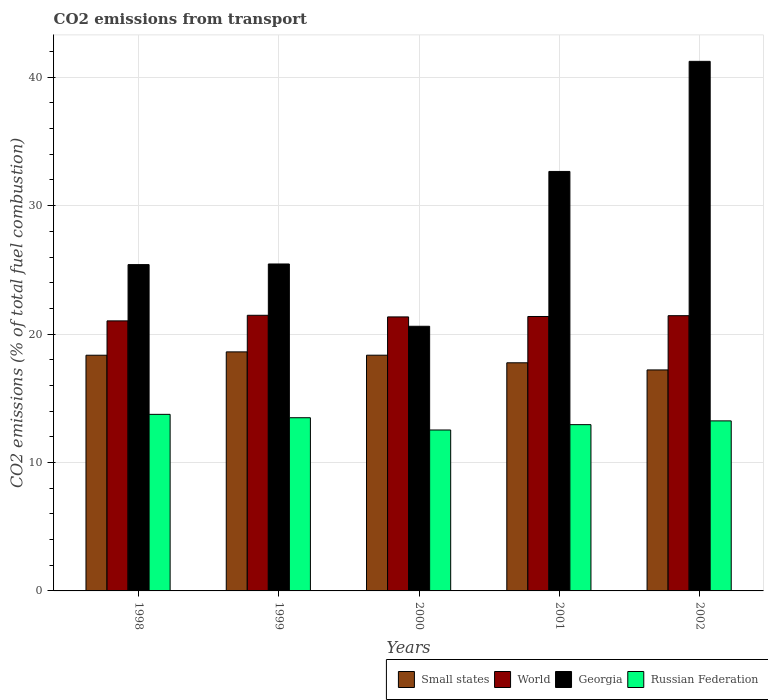How many groups of bars are there?
Ensure brevity in your answer.  5. Are the number of bars per tick equal to the number of legend labels?
Your response must be concise. Yes. Are the number of bars on each tick of the X-axis equal?
Make the answer very short. Yes. How many bars are there on the 2nd tick from the left?
Your answer should be very brief. 4. In how many cases, is the number of bars for a given year not equal to the number of legend labels?
Offer a very short reply. 0. What is the total CO2 emitted in Georgia in 1998?
Offer a very short reply. 25.41. Across all years, what is the maximum total CO2 emitted in Small states?
Ensure brevity in your answer.  18.61. Across all years, what is the minimum total CO2 emitted in Georgia?
Your response must be concise. 20.61. In which year was the total CO2 emitted in World maximum?
Provide a short and direct response. 1999. In which year was the total CO2 emitted in Russian Federation minimum?
Offer a terse response. 2000. What is the total total CO2 emitted in Small states in the graph?
Make the answer very short. 90.3. What is the difference between the total CO2 emitted in Russian Federation in 2000 and that in 2002?
Make the answer very short. -0.71. What is the difference between the total CO2 emitted in Georgia in 1998 and the total CO2 emitted in Russian Federation in 1999?
Your response must be concise. 11.92. What is the average total CO2 emitted in Russian Federation per year?
Keep it short and to the point. 13.19. In the year 2001, what is the difference between the total CO2 emitted in World and total CO2 emitted in Small states?
Your response must be concise. 3.61. In how many years, is the total CO2 emitted in Small states greater than 10?
Provide a succinct answer. 5. What is the ratio of the total CO2 emitted in World in 1998 to that in 2000?
Provide a succinct answer. 0.99. What is the difference between the highest and the second highest total CO2 emitted in Georgia?
Keep it short and to the point. 8.57. What is the difference between the highest and the lowest total CO2 emitted in Small states?
Provide a succinct answer. 1.41. In how many years, is the total CO2 emitted in World greater than the average total CO2 emitted in World taken over all years?
Your response must be concise. 4. Is it the case that in every year, the sum of the total CO2 emitted in Georgia and total CO2 emitted in Russian Federation is greater than the sum of total CO2 emitted in World and total CO2 emitted in Small states?
Your answer should be very brief. No. What does the 3rd bar from the left in 2002 represents?
Ensure brevity in your answer.  Georgia. What does the 1st bar from the right in 2000 represents?
Make the answer very short. Russian Federation. Is it the case that in every year, the sum of the total CO2 emitted in World and total CO2 emitted in Russian Federation is greater than the total CO2 emitted in Georgia?
Make the answer very short. No. How many bars are there?
Provide a succinct answer. 20. How many years are there in the graph?
Ensure brevity in your answer.  5. What is the difference between two consecutive major ticks on the Y-axis?
Provide a succinct answer. 10. Does the graph contain any zero values?
Provide a short and direct response. No. How many legend labels are there?
Your response must be concise. 4. What is the title of the graph?
Provide a succinct answer. CO2 emissions from transport. Does "Lower middle income" appear as one of the legend labels in the graph?
Your answer should be very brief. No. What is the label or title of the Y-axis?
Provide a short and direct response. CO2 emissions (% of total fuel combustion). What is the CO2 emissions (% of total fuel combustion) in Small states in 1998?
Ensure brevity in your answer.  18.35. What is the CO2 emissions (% of total fuel combustion) of World in 1998?
Your answer should be very brief. 21.03. What is the CO2 emissions (% of total fuel combustion) of Georgia in 1998?
Your answer should be very brief. 25.41. What is the CO2 emissions (% of total fuel combustion) in Russian Federation in 1998?
Keep it short and to the point. 13.75. What is the CO2 emissions (% of total fuel combustion) of Small states in 1999?
Ensure brevity in your answer.  18.61. What is the CO2 emissions (% of total fuel combustion) in World in 1999?
Offer a terse response. 21.46. What is the CO2 emissions (% of total fuel combustion) in Georgia in 1999?
Offer a very short reply. 25.46. What is the CO2 emissions (% of total fuel combustion) in Russian Federation in 1999?
Keep it short and to the point. 13.49. What is the CO2 emissions (% of total fuel combustion) of Small states in 2000?
Ensure brevity in your answer.  18.36. What is the CO2 emissions (% of total fuel combustion) of World in 2000?
Keep it short and to the point. 21.34. What is the CO2 emissions (% of total fuel combustion) in Georgia in 2000?
Give a very brief answer. 20.61. What is the CO2 emissions (% of total fuel combustion) in Russian Federation in 2000?
Offer a very short reply. 12.53. What is the CO2 emissions (% of total fuel combustion) of Small states in 2001?
Give a very brief answer. 17.76. What is the CO2 emissions (% of total fuel combustion) in World in 2001?
Keep it short and to the point. 21.37. What is the CO2 emissions (% of total fuel combustion) in Georgia in 2001?
Offer a very short reply. 32.66. What is the CO2 emissions (% of total fuel combustion) of Russian Federation in 2001?
Your answer should be very brief. 12.95. What is the CO2 emissions (% of total fuel combustion) of Small states in 2002?
Provide a short and direct response. 17.21. What is the CO2 emissions (% of total fuel combustion) in World in 2002?
Ensure brevity in your answer.  21.43. What is the CO2 emissions (% of total fuel combustion) of Georgia in 2002?
Your response must be concise. 41.24. What is the CO2 emissions (% of total fuel combustion) in Russian Federation in 2002?
Your response must be concise. 13.24. Across all years, what is the maximum CO2 emissions (% of total fuel combustion) of Small states?
Ensure brevity in your answer.  18.61. Across all years, what is the maximum CO2 emissions (% of total fuel combustion) in World?
Give a very brief answer. 21.46. Across all years, what is the maximum CO2 emissions (% of total fuel combustion) in Georgia?
Keep it short and to the point. 41.24. Across all years, what is the maximum CO2 emissions (% of total fuel combustion) of Russian Federation?
Your response must be concise. 13.75. Across all years, what is the minimum CO2 emissions (% of total fuel combustion) of Small states?
Your answer should be very brief. 17.21. Across all years, what is the minimum CO2 emissions (% of total fuel combustion) in World?
Offer a very short reply. 21.03. Across all years, what is the minimum CO2 emissions (% of total fuel combustion) of Georgia?
Offer a very short reply. 20.61. Across all years, what is the minimum CO2 emissions (% of total fuel combustion) in Russian Federation?
Keep it short and to the point. 12.53. What is the total CO2 emissions (% of total fuel combustion) in Small states in the graph?
Your answer should be compact. 90.3. What is the total CO2 emissions (% of total fuel combustion) of World in the graph?
Your answer should be very brief. 106.63. What is the total CO2 emissions (% of total fuel combustion) of Georgia in the graph?
Ensure brevity in your answer.  145.38. What is the total CO2 emissions (% of total fuel combustion) in Russian Federation in the graph?
Offer a very short reply. 65.96. What is the difference between the CO2 emissions (% of total fuel combustion) of Small states in 1998 and that in 1999?
Your answer should be very brief. -0.26. What is the difference between the CO2 emissions (% of total fuel combustion) of World in 1998 and that in 1999?
Provide a succinct answer. -0.43. What is the difference between the CO2 emissions (% of total fuel combustion) in Georgia in 1998 and that in 1999?
Your answer should be very brief. -0.05. What is the difference between the CO2 emissions (% of total fuel combustion) of Russian Federation in 1998 and that in 1999?
Give a very brief answer. 0.26. What is the difference between the CO2 emissions (% of total fuel combustion) in Small states in 1998 and that in 2000?
Your response must be concise. -0. What is the difference between the CO2 emissions (% of total fuel combustion) in World in 1998 and that in 2000?
Give a very brief answer. -0.31. What is the difference between the CO2 emissions (% of total fuel combustion) in Georgia in 1998 and that in 2000?
Your response must be concise. 4.8. What is the difference between the CO2 emissions (% of total fuel combustion) of Russian Federation in 1998 and that in 2000?
Offer a very short reply. 1.22. What is the difference between the CO2 emissions (% of total fuel combustion) in Small states in 1998 and that in 2001?
Give a very brief answer. 0.59. What is the difference between the CO2 emissions (% of total fuel combustion) in World in 1998 and that in 2001?
Provide a short and direct response. -0.34. What is the difference between the CO2 emissions (% of total fuel combustion) in Georgia in 1998 and that in 2001?
Ensure brevity in your answer.  -7.25. What is the difference between the CO2 emissions (% of total fuel combustion) in Russian Federation in 1998 and that in 2001?
Offer a terse response. 0.8. What is the difference between the CO2 emissions (% of total fuel combustion) in Small states in 1998 and that in 2002?
Offer a very short reply. 1.14. What is the difference between the CO2 emissions (% of total fuel combustion) of World in 1998 and that in 2002?
Your response must be concise. -0.4. What is the difference between the CO2 emissions (% of total fuel combustion) of Georgia in 1998 and that in 2002?
Your answer should be compact. -15.83. What is the difference between the CO2 emissions (% of total fuel combustion) of Russian Federation in 1998 and that in 2002?
Ensure brevity in your answer.  0.51. What is the difference between the CO2 emissions (% of total fuel combustion) of Small states in 1999 and that in 2000?
Your response must be concise. 0.26. What is the difference between the CO2 emissions (% of total fuel combustion) in World in 1999 and that in 2000?
Your answer should be very brief. 0.13. What is the difference between the CO2 emissions (% of total fuel combustion) of Georgia in 1999 and that in 2000?
Give a very brief answer. 4.85. What is the difference between the CO2 emissions (% of total fuel combustion) in Russian Federation in 1999 and that in 2000?
Your response must be concise. 0.96. What is the difference between the CO2 emissions (% of total fuel combustion) of Small states in 1999 and that in 2001?
Provide a succinct answer. 0.85. What is the difference between the CO2 emissions (% of total fuel combustion) of World in 1999 and that in 2001?
Ensure brevity in your answer.  0.09. What is the difference between the CO2 emissions (% of total fuel combustion) in Georgia in 1999 and that in 2001?
Your answer should be compact. -7.21. What is the difference between the CO2 emissions (% of total fuel combustion) in Russian Federation in 1999 and that in 2001?
Ensure brevity in your answer.  0.54. What is the difference between the CO2 emissions (% of total fuel combustion) in Small states in 1999 and that in 2002?
Provide a short and direct response. 1.41. What is the difference between the CO2 emissions (% of total fuel combustion) of World in 1999 and that in 2002?
Your answer should be compact. 0.03. What is the difference between the CO2 emissions (% of total fuel combustion) of Georgia in 1999 and that in 2002?
Provide a short and direct response. -15.78. What is the difference between the CO2 emissions (% of total fuel combustion) in Russian Federation in 1999 and that in 2002?
Keep it short and to the point. 0.25. What is the difference between the CO2 emissions (% of total fuel combustion) in Small states in 2000 and that in 2001?
Offer a terse response. 0.59. What is the difference between the CO2 emissions (% of total fuel combustion) in World in 2000 and that in 2001?
Offer a very short reply. -0.03. What is the difference between the CO2 emissions (% of total fuel combustion) of Georgia in 2000 and that in 2001?
Ensure brevity in your answer.  -12.06. What is the difference between the CO2 emissions (% of total fuel combustion) of Russian Federation in 2000 and that in 2001?
Make the answer very short. -0.42. What is the difference between the CO2 emissions (% of total fuel combustion) of Small states in 2000 and that in 2002?
Keep it short and to the point. 1.15. What is the difference between the CO2 emissions (% of total fuel combustion) in World in 2000 and that in 2002?
Offer a very short reply. -0.1. What is the difference between the CO2 emissions (% of total fuel combustion) in Georgia in 2000 and that in 2002?
Offer a terse response. -20.63. What is the difference between the CO2 emissions (% of total fuel combustion) in Russian Federation in 2000 and that in 2002?
Provide a succinct answer. -0.71. What is the difference between the CO2 emissions (% of total fuel combustion) in Small states in 2001 and that in 2002?
Make the answer very short. 0.56. What is the difference between the CO2 emissions (% of total fuel combustion) of World in 2001 and that in 2002?
Provide a succinct answer. -0.06. What is the difference between the CO2 emissions (% of total fuel combustion) in Georgia in 2001 and that in 2002?
Your answer should be compact. -8.57. What is the difference between the CO2 emissions (% of total fuel combustion) of Russian Federation in 2001 and that in 2002?
Your answer should be compact. -0.29. What is the difference between the CO2 emissions (% of total fuel combustion) in Small states in 1998 and the CO2 emissions (% of total fuel combustion) in World in 1999?
Offer a very short reply. -3.11. What is the difference between the CO2 emissions (% of total fuel combustion) of Small states in 1998 and the CO2 emissions (% of total fuel combustion) of Georgia in 1999?
Offer a very short reply. -7.11. What is the difference between the CO2 emissions (% of total fuel combustion) of Small states in 1998 and the CO2 emissions (% of total fuel combustion) of Russian Federation in 1999?
Your answer should be compact. 4.87. What is the difference between the CO2 emissions (% of total fuel combustion) in World in 1998 and the CO2 emissions (% of total fuel combustion) in Georgia in 1999?
Keep it short and to the point. -4.43. What is the difference between the CO2 emissions (% of total fuel combustion) in World in 1998 and the CO2 emissions (% of total fuel combustion) in Russian Federation in 1999?
Provide a short and direct response. 7.54. What is the difference between the CO2 emissions (% of total fuel combustion) in Georgia in 1998 and the CO2 emissions (% of total fuel combustion) in Russian Federation in 1999?
Ensure brevity in your answer.  11.92. What is the difference between the CO2 emissions (% of total fuel combustion) of Small states in 1998 and the CO2 emissions (% of total fuel combustion) of World in 2000?
Your answer should be very brief. -2.98. What is the difference between the CO2 emissions (% of total fuel combustion) in Small states in 1998 and the CO2 emissions (% of total fuel combustion) in Georgia in 2000?
Keep it short and to the point. -2.25. What is the difference between the CO2 emissions (% of total fuel combustion) of Small states in 1998 and the CO2 emissions (% of total fuel combustion) of Russian Federation in 2000?
Offer a very short reply. 5.82. What is the difference between the CO2 emissions (% of total fuel combustion) in World in 1998 and the CO2 emissions (% of total fuel combustion) in Georgia in 2000?
Offer a terse response. 0.42. What is the difference between the CO2 emissions (% of total fuel combustion) of World in 1998 and the CO2 emissions (% of total fuel combustion) of Russian Federation in 2000?
Offer a very short reply. 8.5. What is the difference between the CO2 emissions (% of total fuel combustion) of Georgia in 1998 and the CO2 emissions (% of total fuel combustion) of Russian Federation in 2000?
Ensure brevity in your answer.  12.88. What is the difference between the CO2 emissions (% of total fuel combustion) of Small states in 1998 and the CO2 emissions (% of total fuel combustion) of World in 2001?
Your answer should be compact. -3.02. What is the difference between the CO2 emissions (% of total fuel combustion) in Small states in 1998 and the CO2 emissions (% of total fuel combustion) in Georgia in 2001?
Provide a short and direct response. -14.31. What is the difference between the CO2 emissions (% of total fuel combustion) in Small states in 1998 and the CO2 emissions (% of total fuel combustion) in Russian Federation in 2001?
Offer a terse response. 5.41. What is the difference between the CO2 emissions (% of total fuel combustion) in World in 1998 and the CO2 emissions (% of total fuel combustion) in Georgia in 2001?
Give a very brief answer. -11.64. What is the difference between the CO2 emissions (% of total fuel combustion) of World in 1998 and the CO2 emissions (% of total fuel combustion) of Russian Federation in 2001?
Provide a succinct answer. 8.08. What is the difference between the CO2 emissions (% of total fuel combustion) of Georgia in 1998 and the CO2 emissions (% of total fuel combustion) of Russian Federation in 2001?
Make the answer very short. 12.46. What is the difference between the CO2 emissions (% of total fuel combustion) of Small states in 1998 and the CO2 emissions (% of total fuel combustion) of World in 2002?
Your answer should be very brief. -3.08. What is the difference between the CO2 emissions (% of total fuel combustion) in Small states in 1998 and the CO2 emissions (% of total fuel combustion) in Georgia in 2002?
Your response must be concise. -22.88. What is the difference between the CO2 emissions (% of total fuel combustion) in Small states in 1998 and the CO2 emissions (% of total fuel combustion) in Russian Federation in 2002?
Your response must be concise. 5.11. What is the difference between the CO2 emissions (% of total fuel combustion) of World in 1998 and the CO2 emissions (% of total fuel combustion) of Georgia in 2002?
Ensure brevity in your answer.  -20.21. What is the difference between the CO2 emissions (% of total fuel combustion) of World in 1998 and the CO2 emissions (% of total fuel combustion) of Russian Federation in 2002?
Offer a terse response. 7.79. What is the difference between the CO2 emissions (% of total fuel combustion) of Georgia in 1998 and the CO2 emissions (% of total fuel combustion) of Russian Federation in 2002?
Provide a succinct answer. 12.17. What is the difference between the CO2 emissions (% of total fuel combustion) of Small states in 1999 and the CO2 emissions (% of total fuel combustion) of World in 2000?
Your answer should be very brief. -2.72. What is the difference between the CO2 emissions (% of total fuel combustion) of Small states in 1999 and the CO2 emissions (% of total fuel combustion) of Georgia in 2000?
Your answer should be very brief. -1.99. What is the difference between the CO2 emissions (% of total fuel combustion) of Small states in 1999 and the CO2 emissions (% of total fuel combustion) of Russian Federation in 2000?
Keep it short and to the point. 6.08. What is the difference between the CO2 emissions (% of total fuel combustion) in World in 1999 and the CO2 emissions (% of total fuel combustion) in Georgia in 2000?
Offer a terse response. 0.86. What is the difference between the CO2 emissions (% of total fuel combustion) of World in 1999 and the CO2 emissions (% of total fuel combustion) of Russian Federation in 2000?
Offer a terse response. 8.93. What is the difference between the CO2 emissions (% of total fuel combustion) in Georgia in 1999 and the CO2 emissions (% of total fuel combustion) in Russian Federation in 2000?
Make the answer very short. 12.93. What is the difference between the CO2 emissions (% of total fuel combustion) of Small states in 1999 and the CO2 emissions (% of total fuel combustion) of World in 2001?
Make the answer very short. -2.76. What is the difference between the CO2 emissions (% of total fuel combustion) in Small states in 1999 and the CO2 emissions (% of total fuel combustion) in Georgia in 2001?
Offer a terse response. -14.05. What is the difference between the CO2 emissions (% of total fuel combustion) of Small states in 1999 and the CO2 emissions (% of total fuel combustion) of Russian Federation in 2001?
Offer a terse response. 5.67. What is the difference between the CO2 emissions (% of total fuel combustion) of World in 1999 and the CO2 emissions (% of total fuel combustion) of Georgia in 2001?
Your answer should be compact. -11.2. What is the difference between the CO2 emissions (% of total fuel combustion) of World in 1999 and the CO2 emissions (% of total fuel combustion) of Russian Federation in 2001?
Your answer should be compact. 8.52. What is the difference between the CO2 emissions (% of total fuel combustion) in Georgia in 1999 and the CO2 emissions (% of total fuel combustion) in Russian Federation in 2001?
Ensure brevity in your answer.  12.51. What is the difference between the CO2 emissions (% of total fuel combustion) in Small states in 1999 and the CO2 emissions (% of total fuel combustion) in World in 2002?
Provide a short and direct response. -2.82. What is the difference between the CO2 emissions (% of total fuel combustion) in Small states in 1999 and the CO2 emissions (% of total fuel combustion) in Georgia in 2002?
Provide a short and direct response. -22.62. What is the difference between the CO2 emissions (% of total fuel combustion) of Small states in 1999 and the CO2 emissions (% of total fuel combustion) of Russian Federation in 2002?
Make the answer very short. 5.37. What is the difference between the CO2 emissions (% of total fuel combustion) of World in 1999 and the CO2 emissions (% of total fuel combustion) of Georgia in 2002?
Your answer should be compact. -19.77. What is the difference between the CO2 emissions (% of total fuel combustion) in World in 1999 and the CO2 emissions (% of total fuel combustion) in Russian Federation in 2002?
Give a very brief answer. 8.22. What is the difference between the CO2 emissions (% of total fuel combustion) of Georgia in 1999 and the CO2 emissions (% of total fuel combustion) of Russian Federation in 2002?
Your response must be concise. 12.22. What is the difference between the CO2 emissions (% of total fuel combustion) in Small states in 2000 and the CO2 emissions (% of total fuel combustion) in World in 2001?
Offer a terse response. -3.01. What is the difference between the CO2 emissions (% of total fuel combustion) in Small states in 2000 and the CO2 emissions (% of total fuel combustion) in Georgia in 2001?
Offer a very short reply. -14.31. What is the difference between the CO2 emissions (% of total fuel combustion) in Small states in 2000 and the CO2 emissions (% of total fuel combustion) in Russian Federation in 2001?
Provide a short and direct response. 5.41. What is the difference between the CO2 emissions (% of total fuel combustion) of World in 2000 and the CO2 emissions (% of total fuel combustion) of Georgia in 2001?
Your response must be concise. -11.33. What is the difference between the CO2 emissions (% of total fuel combustion) of World in 2000 and the CO2 emissions (% of total fuel combustion) of Russian Federation in 2001?
Your answer should be compact. 8.39. What is the difference between the CO2 emissions (% of total fuel combustion) of Georgia in 2000 and the CO2 emissions (% of total fuel combustion) of Russian Federation in 2001?
Provide a succinct answer. 7.66. What is the difference between the CO2 emissions (% of total fuel combustion) in Small states in 2000 and the CO2 emissions (% of total fuel combustion) in World in 2002?
Make the answer very short. -3.08. What is the difference between the CO2 emissions (% of total fuel combustion) in Small states in 2000 and the CO2 emissions (% of total fuel combustion) in Georgia in 2002?
Your answer should be compact. -22.88. What is the difference between the CO2 emissions (% of total fuel combustion) of Small states in 2000 and the CO2 emissions (% of total fuel combustion) of Russian Federation in 2002?
Give a very brief answer. 5.11. What is the difference between the CO2 emissions (% of total fuel combustion) of World in 2000 and the CO2 emissions (% of total fuel combustion) of Georgia in 2002?
Give a very brief answer. -19.9. What is the difference between the CO2 emissions (% of total fuel combustion) of World in 2000 and the CO2 emissions (% of total fuel combustion) of Russian Federation in 2002?
Your response must be concise. 8.1. What is the difference between the CO2 emissions (% of total fuel combustion) in Georgia in 2000 and the CO2 emissions (% of total fuel combustion) in Russian Federation in 2002?
Ensure brevity in your answer.  7.37. What is the difference between the CO2 emissions (% of total fuel combustion) of Small states in 2001 and the CO2 emissions (% of total fuel combustion) of World in 2002?
Ensure brevity in your answer.  -3.67. What is the difference between the CO2 emissions (% of total fuel combustion) of Small states in 2001 and the CO2 emissions (% of total fuel combustion) of Georgia in 2002?
Your answer should be compact. -23.47. What is the difference between the CO2 emissions (% of total fuel combustion) of Small states in 2001 and the CO2 emissions (% of total fuel combustion) of Russian Federation in 2002?
Offer a very short reply. 4.52. What is the difference between the CO2 emissions (% of total fuel combustion) of World in 2001 and the CO2 emissions (% of total fuel combustion) of Georgia in 2002?
Ensure brevity in your answer.  -19.87. What is the difference between the CO2 emissions (% of total fuel combustion) in World in 2001 and the CO2 emissions (% of total fuel combustion) in Russian Federation in 2002?
Give a very brief answer. 8.13. What is the difference between the CO2 emissions (% of total fuel combustion) in Georgia in 2001 and the CO2 emissions (% of total fuel combustion) in Russian Federation in 2002?
Offer a terse response. 19.42. What is the average CO2 emissions (% of total fuel combustion) of Small states per year?
Provide a succinct answer. 18.06. What is the average CO2 emissions (% of total fuel combustion) of World per year?
Provide a short and direct response. 21.33. What is the average CO2 emissions (% of total fuel combustion) in Georgia per year?
Keep it short and to the point. 29.08. What is the average CO2 emissions (% of total fuel combustion) in Russian Federation per year?
Keep it short and to the point. 13.19. In the year 1998, what is the difference between the CO2 emissions (% of total fuel combustion) of Small states and CO2 emissions (% of total fuel combustion) of World?
Provide a succinct answer. -2.67. In the year 1998, what is the difference between the CO2 emissions (% of total fuel combustion) of Small states and CO2 emissions (% of total fuel combustion) of Georgia?
Ensure brevity in your answer.  -7.06. In the year 1998, what is the difference between the CO2 emissions (% of total fuel combustion) of Small states and CO2 emissions (% of total fuel combustion) of Russian Federation?
Make the answer very short. 4.6. In the year 1998, what is the difference between the CO2 emissions (% of total fuel combustion) of World and CO2 emissions (% of total fuel combustion) of Georgia?
Your answer should be compact. -4.38. In the year 1998, what is the difference between the CO2 emissions (% of total fuel combustion) in World and CO2 emissions (% of total fuel combustion) in Russian Federation?
Ensure brevity in your answer.  7.28. In the year 1998, what is the difference between the CO2 emissions (% of total fuel combustion) of Georgia and CO2 emissions (% of total fuel combustion) of Russian Federation?
Your answer should be compact. 11.66. In the year 1999, what is the difference between the CO2 emissions (% of total fuel combustion) in Small states and CO2 emissions (% of total fuel combustion) in World?
Offer a very short reply. -2.85. In the year 1999, what is the difference between the CO2 emissions (% of total fuel combustion) of Small states and CO2 emissions (% of total fuel combustion) of Georgia?
Your response must be concise. -6.84. In the year 1999, what is the difference between the CO2 emissions (% of total fuel combustion) of Small states and CO2 emissions (% of total fuel combustion) of Russian Federation?
Make the answer very short. 5.13. In the year 1999, what is the difference between the CO2 emissions (% of total fuel combustion) in World and CO2 emissions (% of total fuel combustion) in Georgia?
Your answer should be very brief. -4. In the year 1999, what is the difference between the CO2 emissions (% of total fuel combustion) of World and CO2 emissions (% of total fuel combustion) of Russian Federation?
Provide a succinct answer. 7.98. In the year 1999, what is the difference between the CO2 emissions (% of total fuel combustion) in Georgia and CO2 emissions (% of total fuel combustion) in Russian Federation?
Make the answer very short. 11.97. In the year 2000, what is the difference between the CO2 emissions (% of total fuel combustion) of Small states and CO2 emissions (% of total fuel combustion) of World?
Your response must be concise. -2.98. In the year 2000, what is the difference between the CO2 emissions (% of total fuel combustion) of Small states and CO2 emissions (% of total fuel combustion) of Georgia?
Your answer should be very brief. -2.25. In the year 2000, what is the difference between the CO2 emissions (% of total fuel combustion) of Small states and CO2 emissions (% of total fuel combustion) of Russian Federation?
Your answer should be compact. 5.82. In the year 2000, what is the difference between the CO2 emissions (% of total fuel combustion) of World and CO2 emissions (% of total fuel combustion) of Georgia?
Offer a terse response. 0.73. In the year 2000, what is the difference between the CO2 emissions (% of total fuel combustion) in World and CO2 emissions (% of total fuel combustion) in Russian Federation?
Offer a terse response. 8.81. In the year 2000, what is the difference between the CO2 emissions (% of total fuel combustion) in Georgia and CO2 emissions (% of total fuel combustion) in Russian Federation?
Your answer should be very brief. 8.08. In the year 2001, what is the difference between the CO2 emissions (% of total fuel combustion) of Small states and CO2 emissions (% of total fuel combustion) of World?
Your response must be concise. -3.61. In the year 2001, what is the difference between the CO2 emissions (% of total fuel combustion) in Small states and CO2 emissions (% of total fuel combustion) in Georgia?
Your answer should be very brief. -14.9. In the year 2001, what is the difference between the CO2 emissions (% of total fuel combustion) of Small states and CO2 emissions (% of total fuel combustion) of Russian Federation?
Offer a very short reply. 4.82. In the year 2001, what is the difference between the CO2 emissions (% of total fuel combustion) in World and CO2 emissions (% of total fuel combustion) in Georgia?
Make the answer very short. -11.3. In the year 2001, what is the difference between the CO2 emissions (% of total fuel combustion) in World and CO2 emissions (% of total fuel combustion) in Russian Federation?
Give a very brief answer. 8.42. In the year 2001, what is the difference between the CO2 emissions (% of total fuel combustion) of Georgia and CO2 emissions (% of total fuel combustion) of Russian Federation?
Your response must be concise. 19.72. In the year 2002, what is the difference between the CO2 emissions (% of total fuel combustion) in Small states and CO2 emissions (% of total fuel combustion) in World?
Ensure brevity in your answer.  -4.22. In the year 2002, what is the difference between the CO2 emissions (% of total fuel combustion) in Small states and CO2 emissions (% of total fuel combustion) in Georgia?
Make the answer very short. -24.03. In the year 2002, what is the difference between the CO2 emissions (% of total fuel combustion) of Small states and CO2 emissions (% of total fuel combustion) of Russian Federation?
Provide a short and direct response. 3.97. In the year 2002, what is the difference between the CO2 emissions (% of total fuel combustion) in World and CO2 emissions (% of total fuel combustion) in Georgia?
Your response must be concise. -19.8. In the year 2002, what is the difference between the CO2 emissions (% of total fuel combustion) of World and CO2 emissions (% of total fuel combustion) of Russian Federation?
Your answer should be compact. 8.19. In the year 2002, what is the difference between the CO2 emissions (% of total fuel combustion) in Georgia and CO2 emissions (% of total fuel combustion) in Russian Federation?
Ensure brevity in your answer.  28. What is the ratio of the CO2 emissions (% of total fuel combustion) in World in 1998 to that in 1999?
Provide a short and direct response. 0.98. What is the ratio of the CO2 emissions (% of total fuel combustion) of Russian Federation in 1998 to that in 1999?
Keep it short and to the point. 1.02. What is the ratio of the CO2 emissions (% of total fuel combustion) in Small states in 1998 to that in 2000?
Your answer should be very brief. 1. What is the ratio of the CO2 emissions (% of total fuel combustion) in World in 1998 to that in 2000?
Keep it short and to the point. 0.99. What is the ratio of the CO2 emissions (% of total fuel combustion) of Georgia in 1998 to that in 2000?
Your response must be concise. 1.23. What is the ratio of the CO2 emissions (% of total fuel combustion) in Russian Federation in 1998 to that in 2000?
Your answer should be compact. 1.1. What is the ratio of the CO2 emissions (% of total fuel combustion) of Small states in 1998 to that in 2001?
Keep it short and to the point. 1.03. What is the ratio of the CO2 emissions (% of total fuel combustion) in Georgia in 1998 to that in 2001?
Offer a terse response. 0.78. What is the ratio of the CO2 emissions (% of total fuel combustion) of Russian Federation in 1998 to that in 2001?
Your answer should be compact. 1.06. What is the ratio of the CO2 emissions (% of total fuel combustion) of Small states in 1998 to that in 2002?
Provide a succinct answer. 1.07. What is the ratio of the CO2 emissions (% of total fuel combustion) of World in 1998 to that in 2002?
Provide a succinct answer. 0.98. What is the ratio of the CO2 emissions (% of total fuel combustion) of Georgia in 1998 to that in 2002?
Your answer should be compact. 0.62. What is the ratio of the CO2 emissions (% of total fuel combustion) of Russian Federation in 1998 to that in 2002?
Offer a terse response. 1.04. What is the ratio of the CO2 emissions (% of total fuel combustion) in Small states in 1999 to that in 2000?
Provide a succinct answer. 1.01. What is the ratio of the CO2 emissions (% of total fuel combustion) in World in 1999 to that in 2000?
Offer a terse response. 1.01. What is the ratio of the CO2 emissions (% of total fuel combustion) in Georgia in 1999 to that in 2000?
Your answer should be compact. 1.24. What is the ratio of the CO2 emissions (% of total fuel combustion) of Russian Federation in 1999 to that in 2000?
Ensure brevity in your answer.  1.08. What is the ratio of the CO2 emissions (% of total fuel combustion) of Small states in 1999 to that in 2001?
Make the answer very short. 1.05. What is the ratio of the CO2 emissions (% of total fuel combustion) in Georgia in 1999 to that in 2001?
Make the answer very short. 0.78. What is the ratio of the CO2 emissions (% of total fuel combustion) in Russian Federation in 1999 to that in 2001?
Provide a short and direct response. 1.04. What is the ratio of the CO2 emissions (% of total fuel combustion) in Small states in 1999 to that in 2002?
Make the answer very short. 1.08. What is the ratio of the CO2 emissions (% of total fuel combustion) in Georgia in 1999 to that in 2002?
Offer a terse response. 0.62. What is the ratio of the CO2 emissions (% of total fuel combustion) of Russian Federation in 1999 to that in 2002?
Offer a very short reply. 1.02. What is the ratio of the CO2 emissions (% of total fuel combustion) of Small states in 2000 to that in 2001?
Make the answer very short. 1.03. What is the ratio of the CO2 emissions (% of total fuel combustion) in Georgia in 2000 to that in 2001?
Offer a very short reply. 0.63. What is the ratio of the CO2 emissions (% of total fuel combustion) in Russian Federation in 2000 to that in 2001?
Provide a succinct answer. 0.97. What is the ratio of the CO2 emissions (% of total fuel combustion) of Small states in 2000 to that in 2002?
Provide a short and direct response. 1.07. What is the ratio of the CO2 emissions (% of total fuel combustion) of World in 2000 to that in 2002?
Your answer should be very brief. 1. What is the ratio of the CO2 emissions (% of total fuel combustion) of Georgia in 2000 to that in 2002?
Offer a very short reply. 0.5. What is the ratio of the CO2 emissions (% of total fuel combustion) in Russian Federation in 2000 to that in 2002?
Your answer should be very brief. 0.95. What is the ratio of the CO2 emissions (% of total fuel combustion) of Small states in 2001 to that in 2002?
Provide a succinct answer. 1.03. What is the ratio of the CO2 emissions (% of total fuel combustion) in World in 2001 to that in 2002?
Offer a terse response. 1. What is the ratio of the CO2 emissions (% of total fuel combustion) of Georgia in 2001 to that in 2002?
Offer a very short reply. 0.79. What is the ratio of the CO2 emissions (% of total fuel combustion) in Russian Federation in 2001 to that in 2002?
Provide a short and direct response. 0.98. What is the difference between the highest and the second highest CO2 emissions (% of total fuel combustion) of Small states?
Provide a short and direct response. 0.26. What is the difference between the highest and the second highest CO2 emissions (% of total fuel combustion) in World?
Keep it short and to the point. 0.03. What is the difference between the highest and the second highest CO2 emissions (% of total fuel combustion) of Georgia?
Ensure brevity in your answer.  8.57. What is the difference between the highest and the second highest CO2 emissions (% of total fuel combustion) of Russian Federation?
Provide a short and direct response. 0.26. What is the difference between the highest and the lowest CO2 emissions (% of total fuel combustion) of Small states?
Ensure brevity in your answer.  1.41. What is the difference between the highest and the lowest CO2 emissions (% of total fuel combustion) in World?
Give a very brief answer. 0.43. What is the difference between the highest and the lowest CO2 emissions (% of total fuel combustion) in Georgia?
Your answer should be compact. 20.63. What is the difference between the highest and the lowest CO2 emissions (% of total fuel combustion) of Russian Federation?
Offer a terse response. 1.22. 